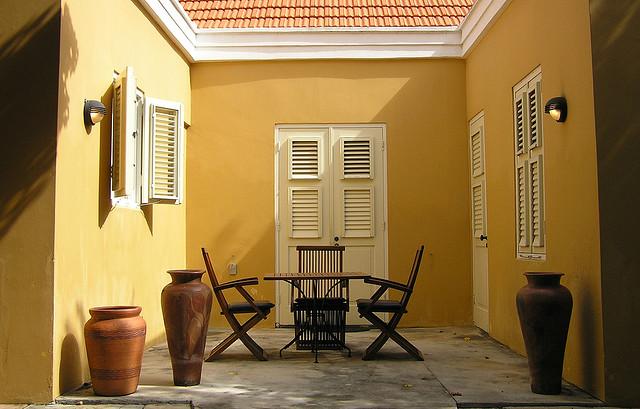Is there a desk in the photo?
Short answer required. No. What color is the wall?
Keep it brief. Yellow. How many vases are in the picture?
Keep it brief. 3. 